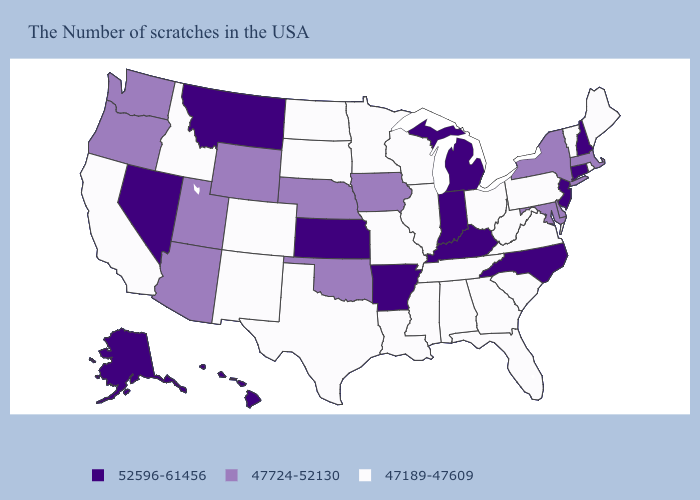Does Arizona have a lower value than New Hampshire?
Write a very short answer. Yes. Among the states that border Ohio , does Pennsylvania have the highest value?
Short answer required. No. What is the value of North Dakota?
Write a very short answer. 47189-47609. Name the states that have a value in the range 47189-47609?
Give a very brief answer. Maine, Rhode Island, Vermont, Pennsylvania, Virginia, South Carolina, West Virginia, Ohio, Florida, Georgia, Alabama, Tennessee, Wisconsin, Illinois, Mississippi, Louisiana, Missouri, Minnesota, Texas, South Dakota, North Dakota, Colorado, New Mexico, Idaho, California. Does New Hampshire have a lower value than Hawaii?
Answer briefly. No. What is the value of Alaska?
Be succinct. 52596-61456. What is the value of Michigan?
Short answer required. 52596-61456. Among the states that border South Dakota , does Wyoming have the highest value?
Keep it brief. No. What is the value of Kansas?
Short answer required. 52596-61456. Does South Dakota have a lower value than Tennessee?
Give a very brief answer. No. Name the states that have a value in the range 47189-47609?
Short answer required. Maine, Rhode Island, Vermont, Pennsylvania, Virginia, South Carolina, West Virginia, Ohio, Florida, Georgia, Alabama, Tennessee, Wisconsin, Illinois, Mississippi, Louisiana, Missouri, Minnesota, Texas, South Dakota, North Dakota, Colorado, New Mexico, Idaho, California. What is the value of New Mexico?
Give a very brief answer. 47189-47609. What is the highest value in states that border Maryland?
Answer briefly. 47724-52130. Name the states that have a value in the range 47724-52130?
Quick response, please. Massachusetts, New York, Delaware, Maryland, Iowa, Nebraska, Oklahoma, Wyoming, Utah, Arizona, Washington, Oregon. Name the states that have a value in the range 47189-47609?
Keep it brief. Maine, Rhode Island, Vermont, Pennsylvania, Virginia, South Carolina, West Virginia, Ohio, Florida, Georgia, Alabama, Tennessee, Wisconsin, Illinois, Mississippi, Louisiana, Missouri, Minnesota, Texas, South Dakota, North Dakota, Colorado, New Mexico, Idaho, California. 